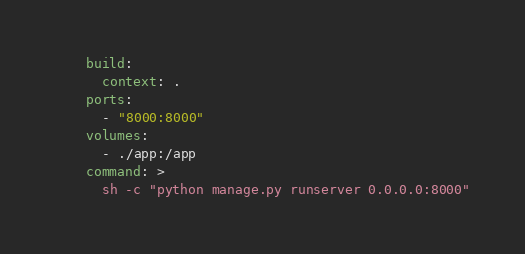<code> <loc_0><loc_0><loc_500><loc_500><_YAML_>    build:
      context: .
    ports:
      - "8000:8000"
    volumes:
      - ./app:/app
    command: >
      sh -c "python manage.py runserver 0.0.0.0:8000"</code> 